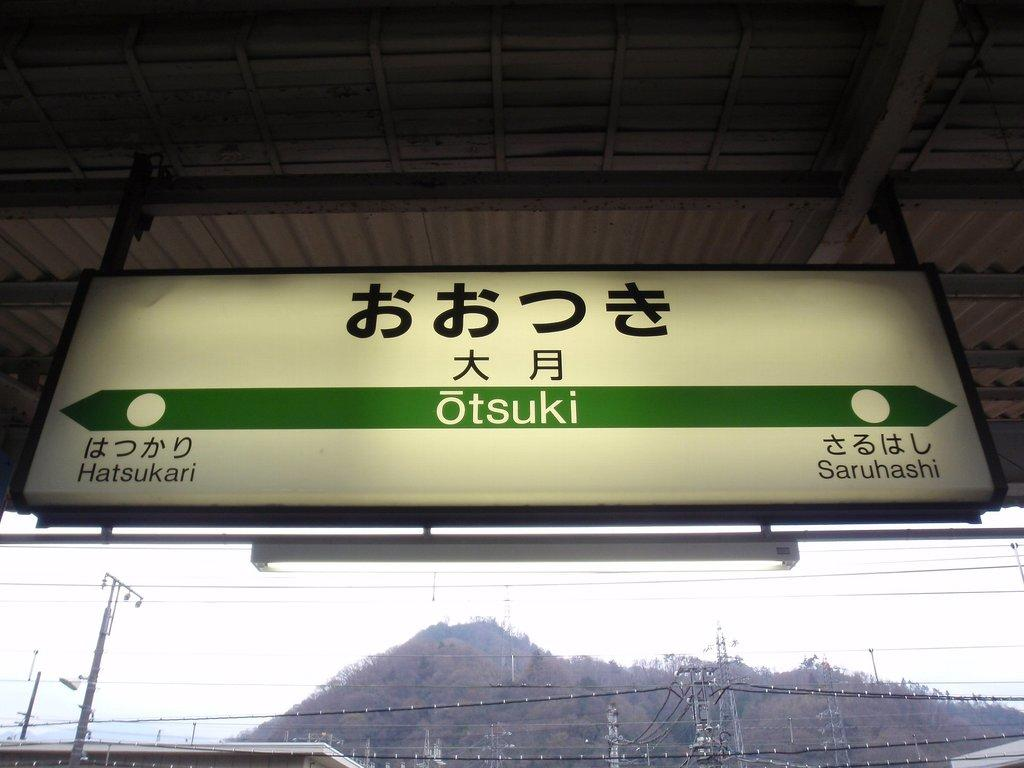<image>
Share a concise interpretation of the image provided. If you turn left at the sign you will go to Hatsukari 